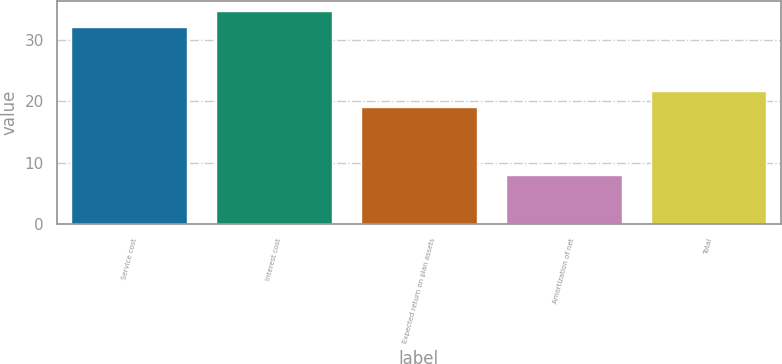Convert chart to OTSL. <chart><loc_0><loc_0><loc_500><loc_500><bar_chart><fcel>Service cost<fcel>Interest cost<fcel>Expected return on plan assets<fcel>Amortization of net<fcel>Total<nl><fcel>32<fcel>34.6<fcel>19<fcel>8<fcel>21.6<nl></chart> 